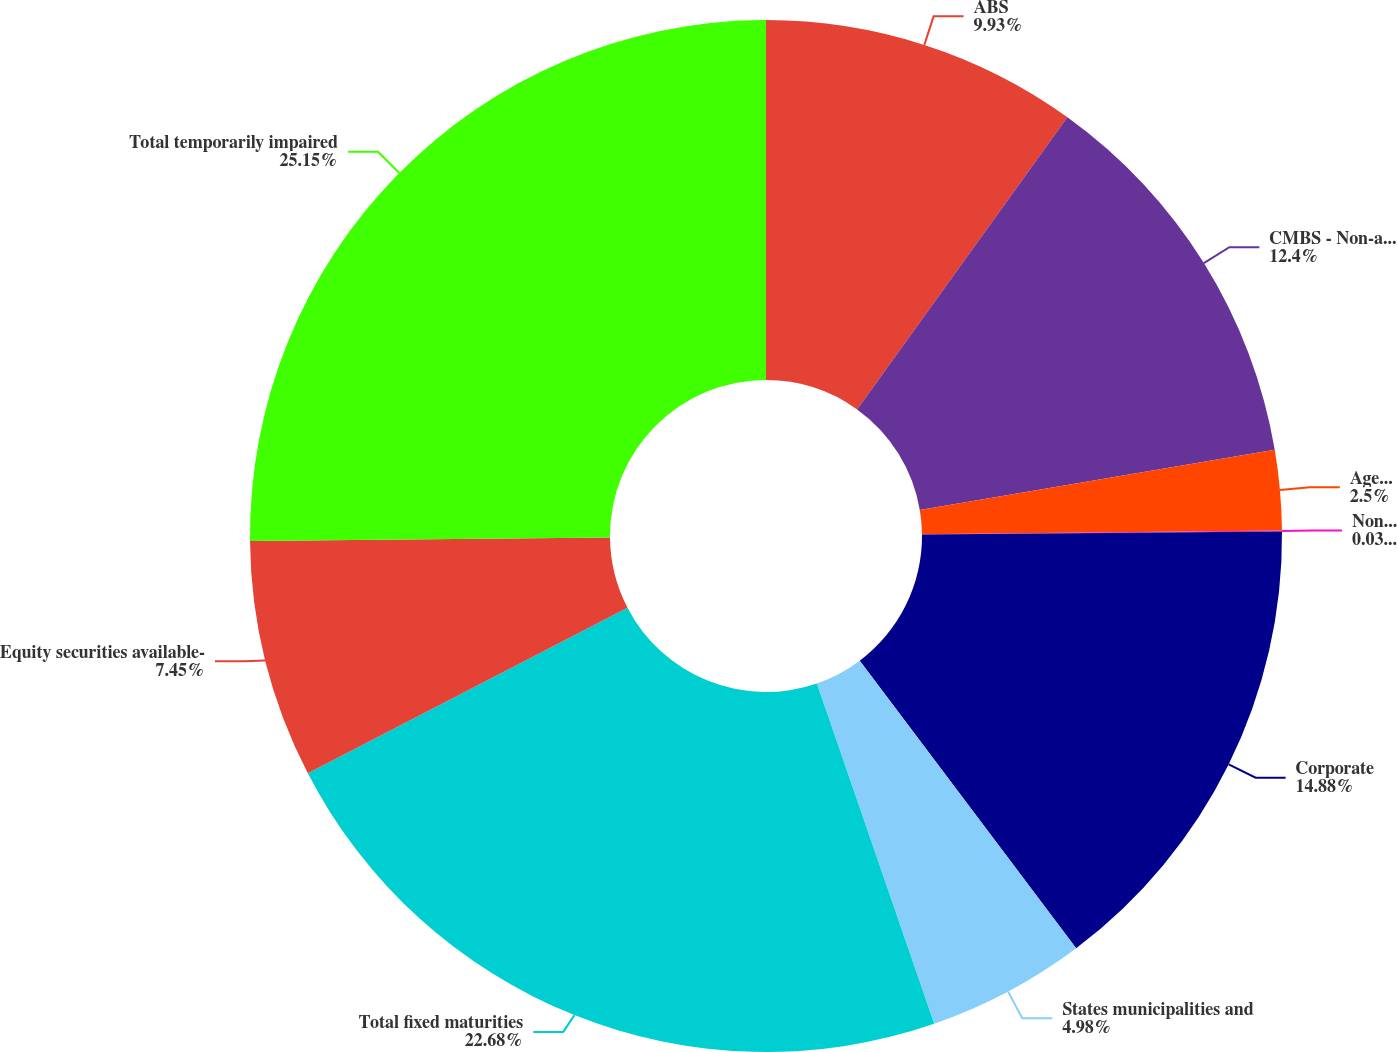<chart> <loc_0><loc_0><loc_500><loc_500><pie_chart><fcel>ABS<fcel>CMBS - Non-agency backed<fcel>Agency backed<fcel>Non-agency backed<fcel>Corporate<fcel>States municipalities and<fcel>Total fixed maturities<fcel>Equity securities available-<fcel>Total temporarily impaired<nl><fcel>9.93%<fcel>12.4%<fcel>2.5%<fcel>0.03%<fcel>14.88%<fcel>4.98%<fcel>22.68%<fcel>7.45%<fcel>25.16%<nl></chart> 